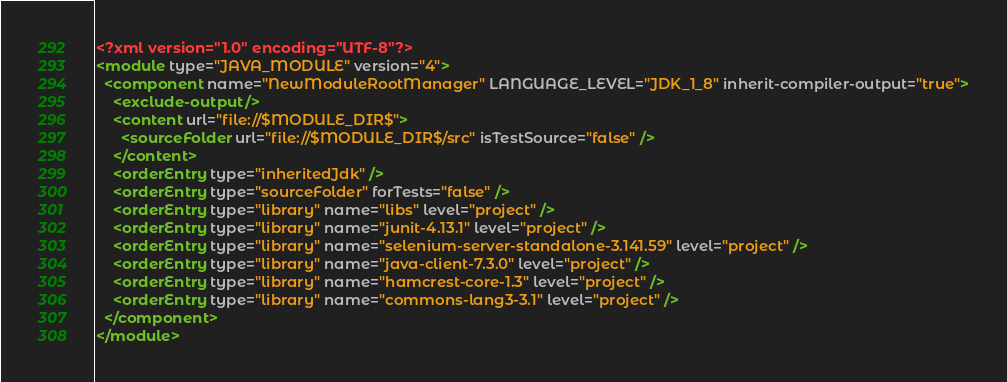<code> <loc_0><loc_0><loc_500><loc_500><_XML_><?xml version="1.0" encoding="UTF-8"?>
<module type="JAVA_MODULE" version="4">
  <component name="NewModuleRootManager" LANGUAGE_LEVEL="JDK_1_8" inherit-compiler-output="true">
    <exclude-output />
    <content url="file://$MODULE_DIR$">
      <sourceFolder url="file://$MODULE_DIR$/src" isTestSource="false" />
    </content>
    <orderEntry type="inheritedJdk" />
    <orderEntry type="sourceFolder" forTests="false" />
    <orderEntry type="library" name="libs" level="project" />
    <orderEntry type="library" name="junit-4.13.1" level="project" />
    <orderEntry type="library" name="selenium-server-standalone-3.141.59" level="project" />
    <orderEntry type="library" name="java-client-7.3.0" level="project" />
    <orderEntry type="library" name="hamcrest-core-1.3" level="project" />
    <orderEntry type="library" name="commons-lang3-3.1" level="project" />
  </component>
</module></code> 